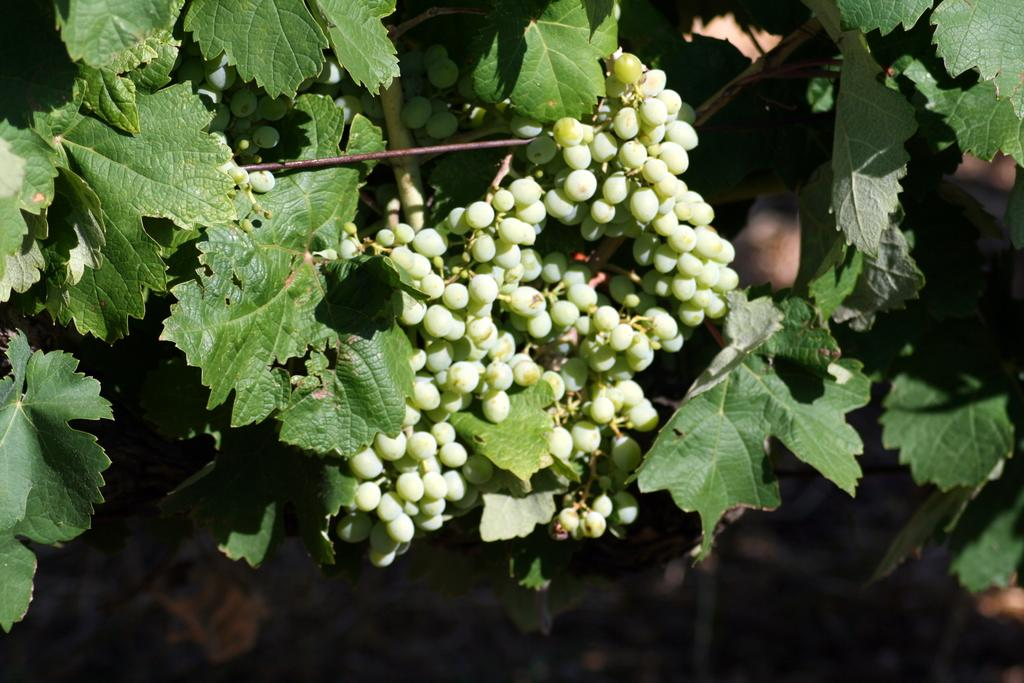What type of vegetation is present in the image? There are leaves in the image. What color are the leaves in the image? The leaves are green. What else is present in the image besides leaves? There are fruits in the image. What color are the fruits in the image? The fruits are green. How many planes can be seen flying over the leaves in the image? There are no planes visible in the image; it only features leaves and fruits. What type of parent is shown interacting with the leaves and fruits in the image? There is no parent present in the image; it only features leaves and fruits. 